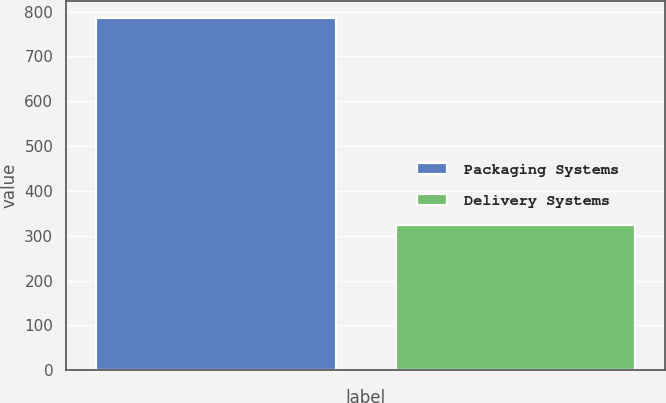Convert chart to OTSL. <chart><loc_0><loc_0><loc_500><loc_500><bar_chart><fcel>Packaging Systems<fcel>Delivery Systems<nl><fcel>785<fcel>324.1<nl></chart> 